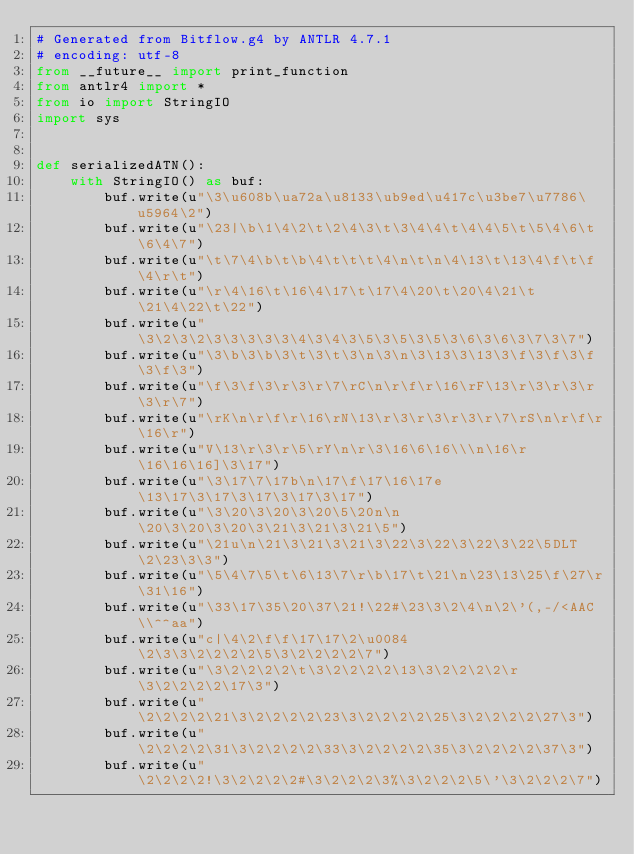Convert code to text. <code><loc_0><loc_0><loc_500><loc_500><_Python_># Generated from Bitflow.g4 by ANTLR 4.7.1
# encoding: utf-8
from __future__ import print_function
from antlr4 import *
from io import StringIO
import sys


def serializedATN():
    with StringIO() as buf:
        buf.write(u"\3\u608b\ua72a\u8133\ub9ed\u417c\u3be7\u7786\u5964\2")
        buf.write(u"\23|\b\1\4\2\t\2\4\3\t\3\4\4\t\4\4\5\t\5\4\6\t\6\4\7")
        buf.write(u"\t\7\4\b\t\b\4\t\t\t\4\n\t\n\4\13\t\13\4\f\t\f\4\r\t")
        buf.write(u"\r\4\16\t\16\4\17\t\17\4\20\t\20\4\21\t\21\4\22\t\22")
        buf.write(u"\3\2\3\2\3\3\3\3\3\4\3\4\3\5\3\5\3\5\3\6\3\6\3\7\3\7")
        buf.write(u"\3\b\3\b\3\t\3\t\3\n\3\n\3\13\3\13\3\f\3\f\3\f\3\f\3")
        buf.write(u"\f\3\f\3\r\3\r\7\rC\n\r\f\r\16\rF\13\r\3\r\3\r\3\r\7")
        buf.write(u"\rK\n\r\f\r\16\rN\13\r\3\r\3\r\3\r\7\rS\n\r\f\r\16\r")
        buf.write(u"V\13\r\3\r\5\rY\n\r\3\16\6\16\\\n\16\r\16\16\16]\3\17")
        buf.write(u"\3\17\7\17b\n\17\f\17\16\17e\13\17\3\17\3\17\3\17\3\17")
        buf.write(u"\3\20\3\20\3\20\5\20n\n\20\3\20\3\20\3\21\3\21\3\21\5")
        buf.write(u"\21u\n\21\3\21\3\21\3\22\3\22\3\22\3\22\5DLT\2\23\3\3")
        buf.write(u"\5\4\7\5\t\6\13\7\r\b\17\t\21\n\23\13\25\f\27\r\31\16")
        buf.write(u"\33\17\35\20\37\21!\22#\23\3\2\4\n\2\'(,-/<AAC\\^^aa")
        buf.write(u"c|\4\2\f\f\17\17\2\u0084\2\3\3\2\2\2\2\5\3\2\2\2\2\7")
        buf.write(u"\3\2\2\2\2\t\3\2\2\2\2\13\3\2\2\2\2\r\3\2\2\2\2\17\3")
        buf.write(u"\2\2\2\2\21\3\2\2\2\2\23\3\2\2\2\2\25\3\2\2\2\2\27\3")
        buf.write(u"\2\2\2\2\31\3\2\2\2\2\33\3\2\2\2\2\35\3\2\2\2\2\37\3")
        buf.write(u"\2\2\2\2!\3\2\2\2\2#\3\2\2\2\3%\3\2\2\2\5\'\3\2\2\2\7")</code> 